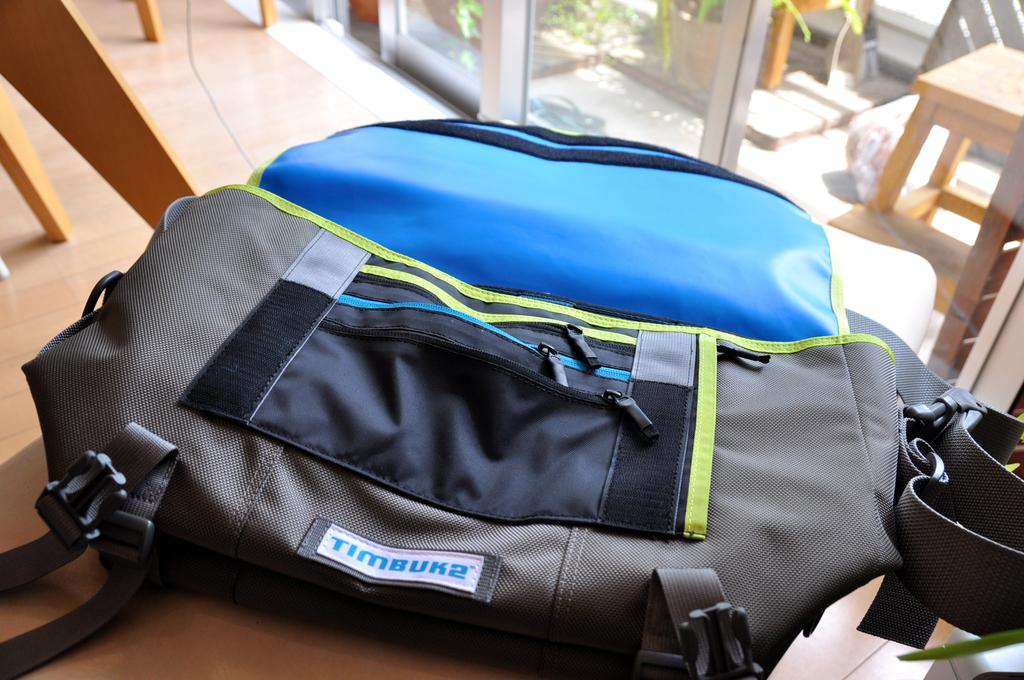What is the main object in the center of the image? There is a bag in the center of the image. Where is the bag located? The bag is on the floor. What can be seen in the background of the image? There are glass windows, chairs, stools, plants, and the floor visible in the background. Can you describe the unspecified objects in the background? Unfortunately, the facts provided do not specify the nature of the unspecified objects in the background. What type of sign can be seen in the image? There is no sign present in the image. How quiet is the environment in the image? The image does not provide any information about the noise level or the environment's quietness. 